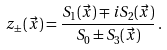Convert formula to latex. <formula><loc_0><loc_0><loc_500><loc_500>z _ { \pm } ( \vec { x } ) = \frac { S _ { 1 } ( \vec { x } ) \mp i S _ { 2 } ( \vec { x } ) } { S _ { 0 } \pm S _ { 3 } ( \vec { x } ) } \, .</formula> 